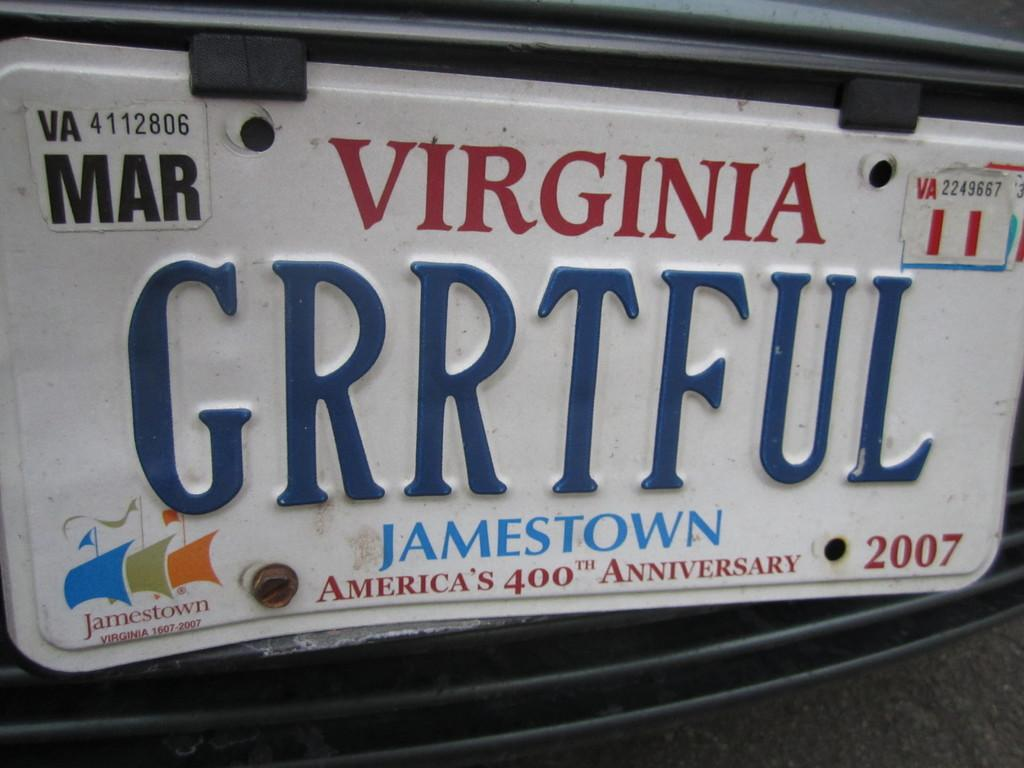<image>
Present a compact description of the photo's key features. White Virginia license plate which says GRRTFUI on it. 